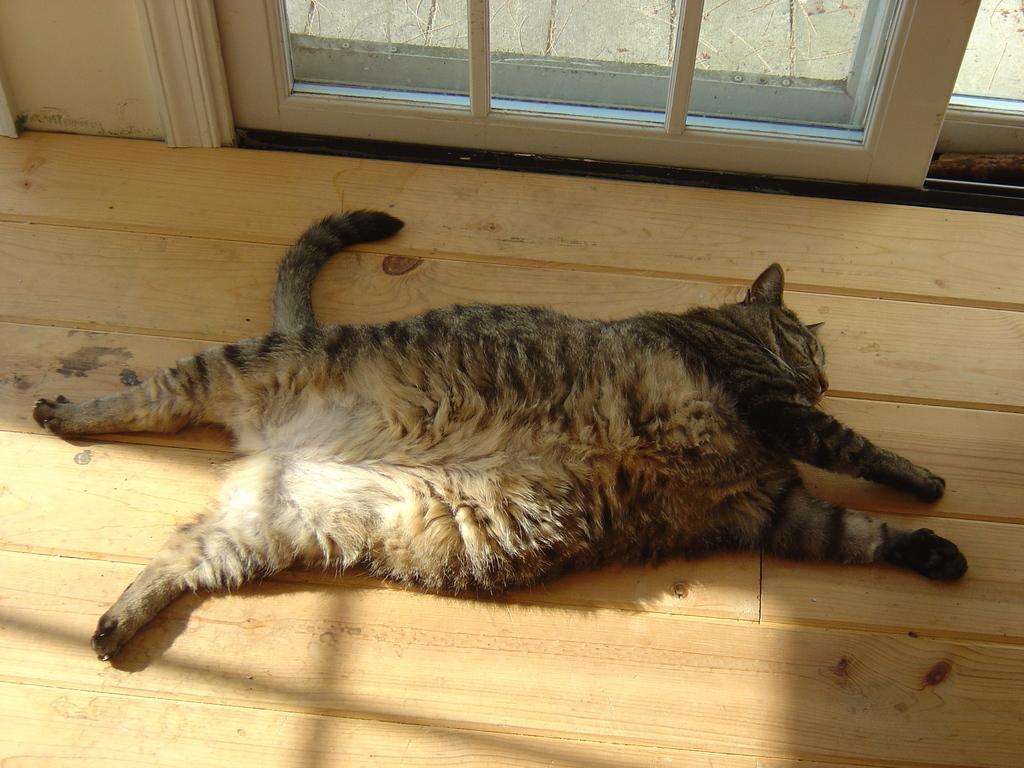What type of animal is present in the image? There is a cat in the image. What surface is the cat lying on? The cat is lying on a wooden floor. Can you identify any other structures or objects in the image? Yes, there is a door in the image. What type of bag can be seen hanging from the cat's tail in the image? There is no bag present in the image, and the cat's tail is not holding anything. Can you see a trail of tin cans behind the cat in the image? There is no trail of tin cans visible in the image. 